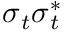Convert formula to latex. <formula><loc_0><loc_0><loc_500><loc_500>\sigma _ { t } \sigma _ { t } ^ { * }</formula> 